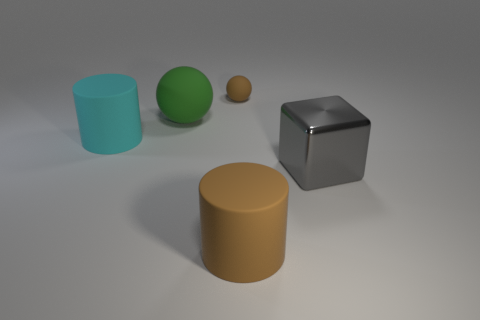Subtract 1 balls. How many balls are left? 1 Subtract all balls. How many objects are left? 3 Subtract all red cylinders. How many green spheres are left? 1 Subtract all gray metallic spheres. Subtract all large objects. How many objects are left? 1 Add 1 green rubber spheres. How many green rubber spheres are left? 2 Add 4 big red matte cubes. How many big red matte cubes exist? 4 Add 1 tiny cyan metal cubes. How many objects exist? 6 Subtract 0 gray balls. How many objects are left? 5 Subtract all red balls. Subtract all cyan cubes. How many balls are left? 2 